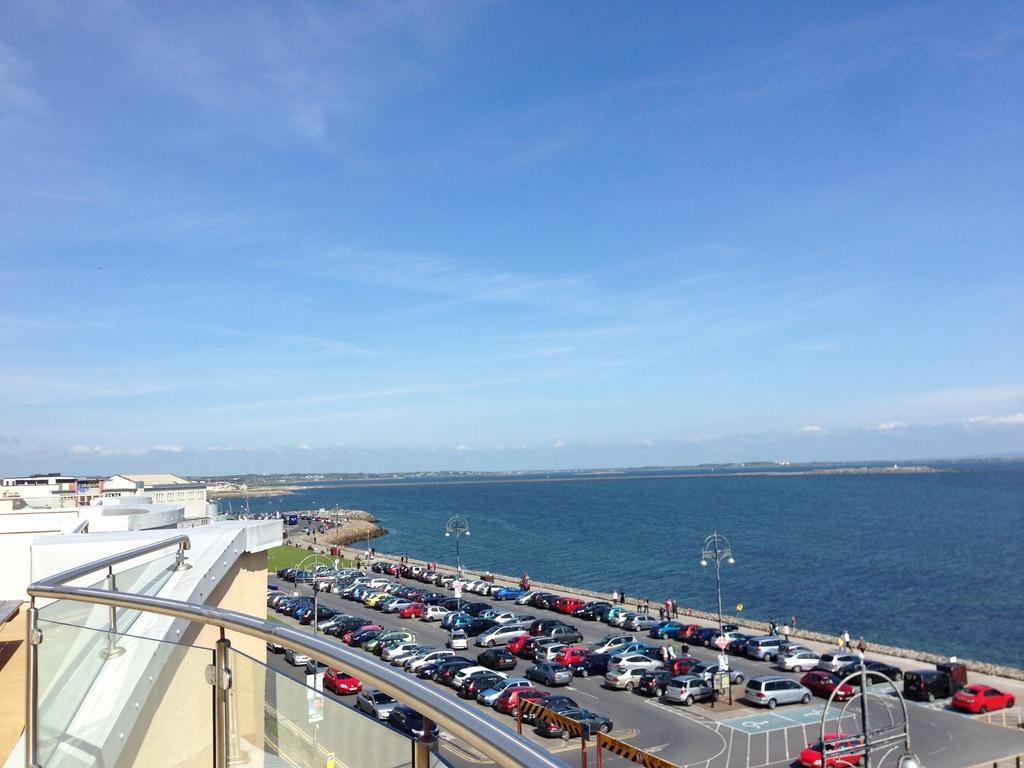Please provide a concise description of this image. In the bottom left corner of the image we can see fencing. Behind the fencing we can see some vehicles, poles, grass and few people are standing and walking. In the middle of the image we can see water and buildings. At the top of the image we can see some clouds in the sky. 